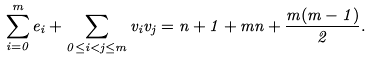<formula> <loc_0><loc_0><loc_500><loc_500>\sum _ { i = 0 } ^ { m } e _ { i } + \sum _ { 0 \leq i < j \leq m } v _ { i } v _ { j } = n + 1 + m n + \frac { m ( m - 1 ) } { 2 } .</formula> 